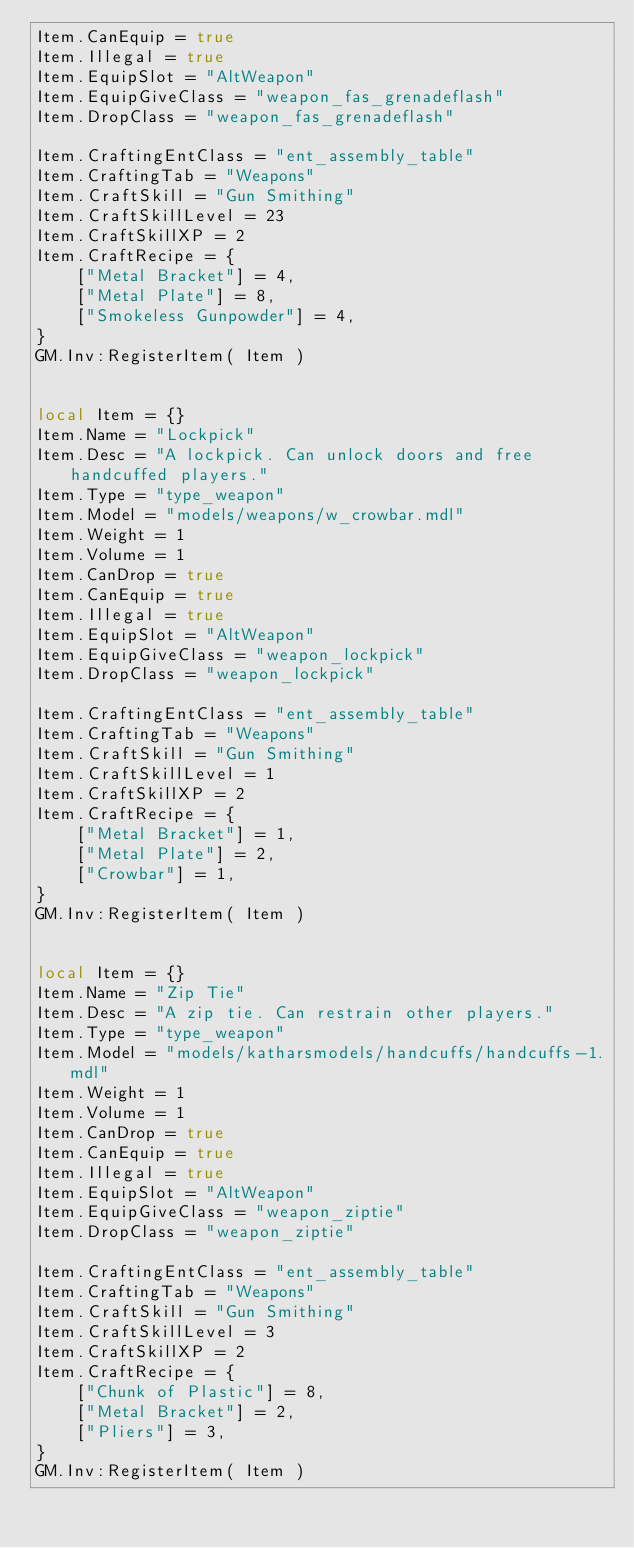<code> <loc_0><loc_0><loc_500><loc_500><_Lua_>Item.CanEquip = true
Item.Illegal = true
Item.EquipSlot = "AltWeapon"
Item.EquipGiveClass = "weapon_fas_grenadeflash"
Item.DropClass = "weapon_fas_grenadeflash"

Item.CraftingEntClass = "ent_assembly_table"
Item.CraftingTab = "Weapons"
Item.CraftSkill = "Gun Smithing"
Item.CraftSkillLevel = 23
Item.CraftSkillXP = 2
Item.CraftRecipe = {
	["Metal Bracket"] = 4,
	["Metal Plate"] = 8,
	["Smokeless Gunpowder"] = 4,
}
GM.Inv:RegisterItem( Item )


local Item = {}
Item.Name = "Lockpick"
Item.Desc = "A lockpick. Can unlock doors and free handcuffed players."
Item.Type = "type_weapon"
Item.Model = "models/weapons/w_crowbar.mdl"
Item.Weight = 1
Item.Volume = 1
Item.CanDrop = true
Item.CanEquip = true
Item.Illegal = true
Item.EquipSlot = "AltWeapon"
Item.EquipGiveClass = "weapon_lockpick"
Item.DropClass = "weapon_lockpick"

Item.CraftingEntClass = "ent_assembly_table"
Item.CraftingTab = "Weapons"
Item.CraftSkill = "Gun Smithing"
Item.CraftSkillLevel = 1
Item.CraftSkillXP = 2
Item.CraftRecipe = {
	["Metal Bracket"] = 1,
	["Metal Plate"] = 2,
	["Crowbar"] = 1,
}
GM.Inv:RegisterItem( Item )


local Item = {}
Item.Name = "Zip Tie"
Item.Desc = "A zip tie. Can restrain other players."
Item.Type = "type_weapon"
Item.Model = "models/katharsmodels/handcuffs/handcuffs-1.mdl"
Item.Weight = 1
Item.Volume = 1
Item.CanDrop = true
Item.CanEquip = true
Item.Illegal = true
Item.EquipSlot = "AltWeapon"
Item.EquipGiveClass = "weapon_ziptie"
Item.DropClass = "weapon_ziptie"

Item.CraftingEntClass = "ent_assembly_table"
Item.CraftingTab = "Weapons"
Item.CraftSkill = "Gun Smithing"
Item.CraftSkillLevel = 3
Item.CraftSkillXP = 2
Item.CraftRecipe = {
	["Chunk of Plastic"] = 8,
	["Metal Bracket"] = 2,
	["Pliers"] = 3,
}
GM.Inv:RegisterItem( Item )</code> 